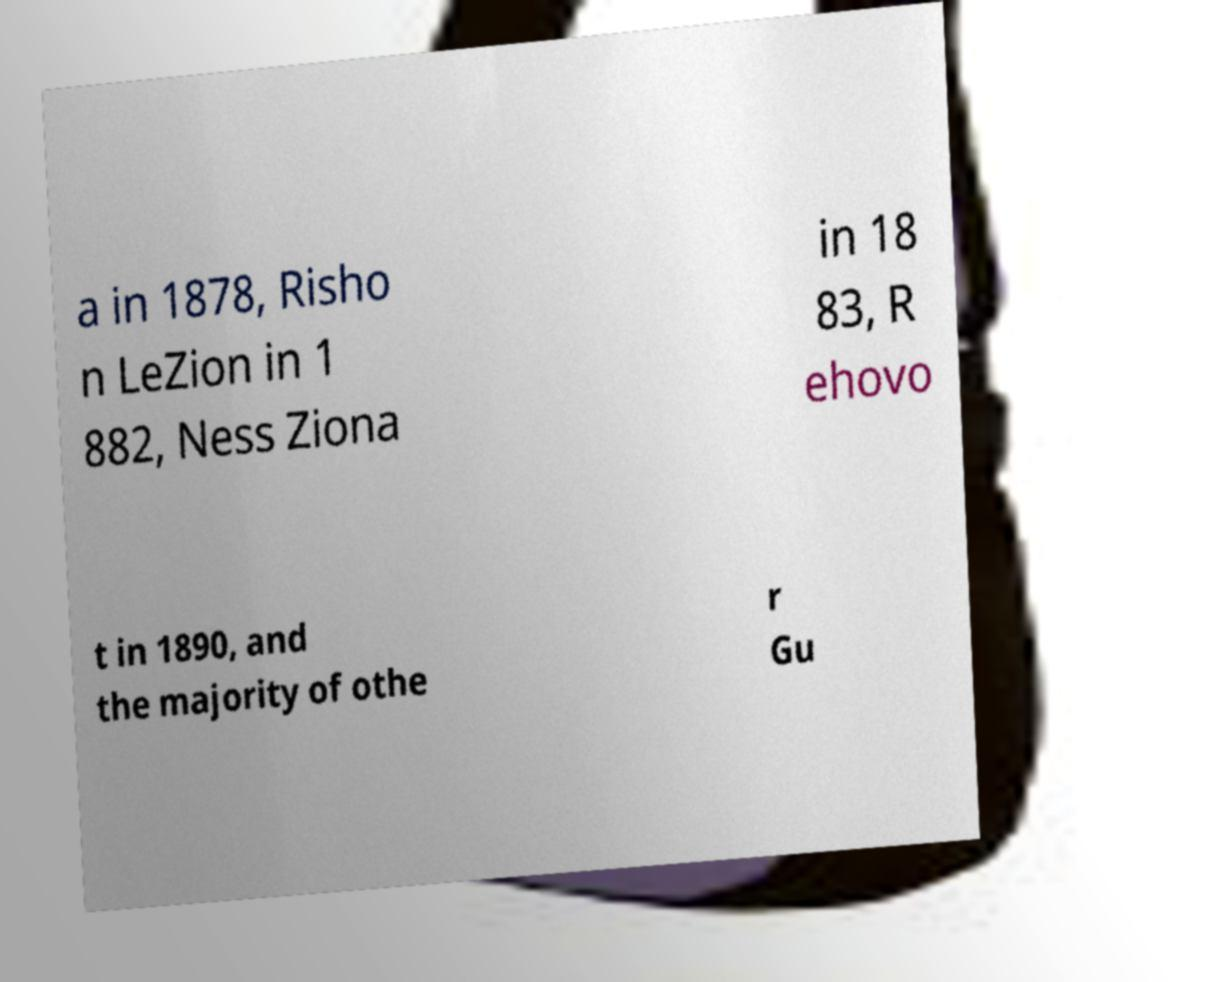Please read and relay the text visible in this image. What does it say? a in 1878, Risho n LeZion in 1 882, Ness Ziona in 18 83, R ehovo t in 1890, and the majority of othe r Gu 